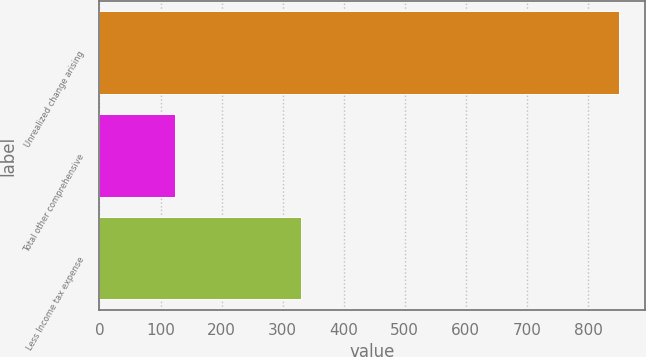Convert chart to OTSL. <chart><loc_0><loc_0><loc_500><loc_500><bar_chart><fcel>Unrealized change arising<fcel>Total other comprehensive<fcel>Less Income tax expense<nl><fcel>851<fcel>123<fcel>330<nl></chart> 